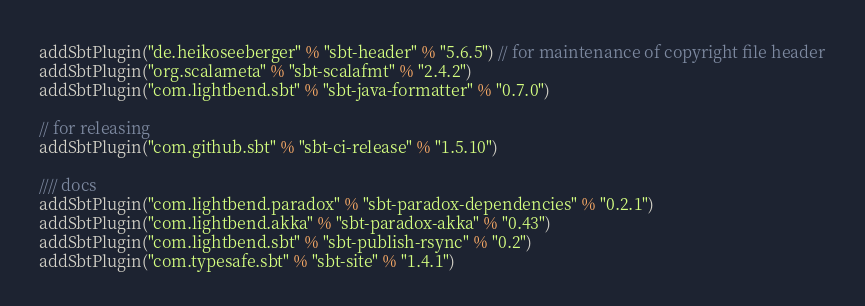Convert code to text. <code><loc_0><loc_0><loc_500><loc_500><_Scala_>addSbtPlugin("de.heikoseeberger" % "sbt-header" % "5.6.5") // for maintenance of copyright file header
addSbtPlugin("org.scalameta" % "sbt-scalafmt" % "2.4.2")
addSbtPlugin("com.lightbend.sbt" % "sbt-java-formatter" % "0.7.0")

// for releasing
addSbtPlugin("com.github.sbt" % "sbt-ci-release" % "1.5.10")

//// docs
addSbtPlugin("com.lightbend.paradox" % "sbt-paradox-dependencies" % "0.2.1")
addSbtPlugin("com.lightbend.akka" % "sbt-paradox-akka" % "0.43")
addSbtPlugin("com.lightbend.sbt" % "sbt-publish-rsync" % "0.2")
addSbtPlugin("com.typesafe.sbt" % "sbt-site" % "1.4.1")
</code> 